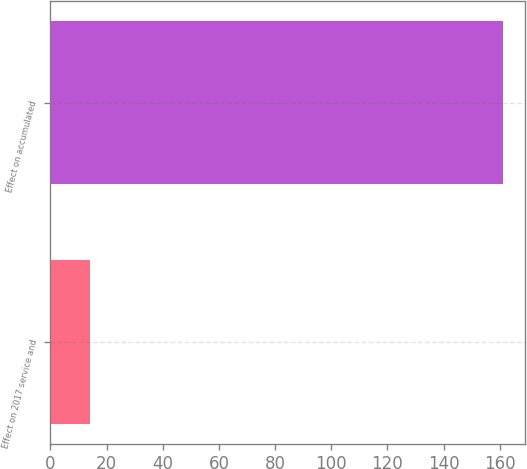Convert chart to OTSL. <chart><loc_0><loc_0><loc_500><loc_500><bar_chart><fcel>Effect on 2017 service and<fcel>Effect on accumulated<nl><fcel>14<fcel>161<nl></chart> 